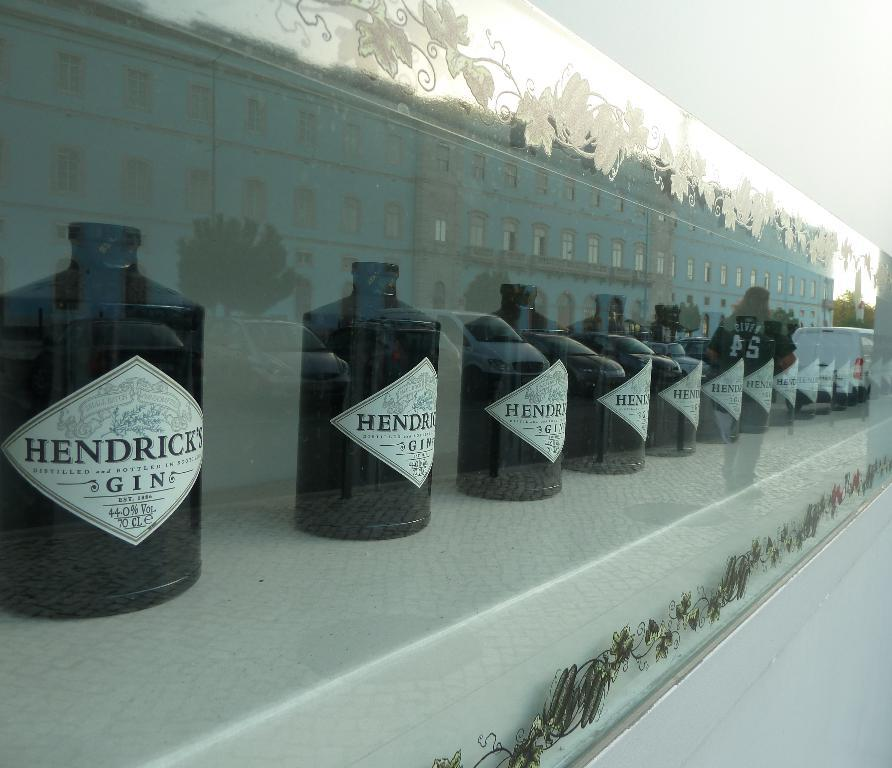<image>
Create a compact narrative representing the image presented. Several bottles of Hendrick's Gin are lined up. 